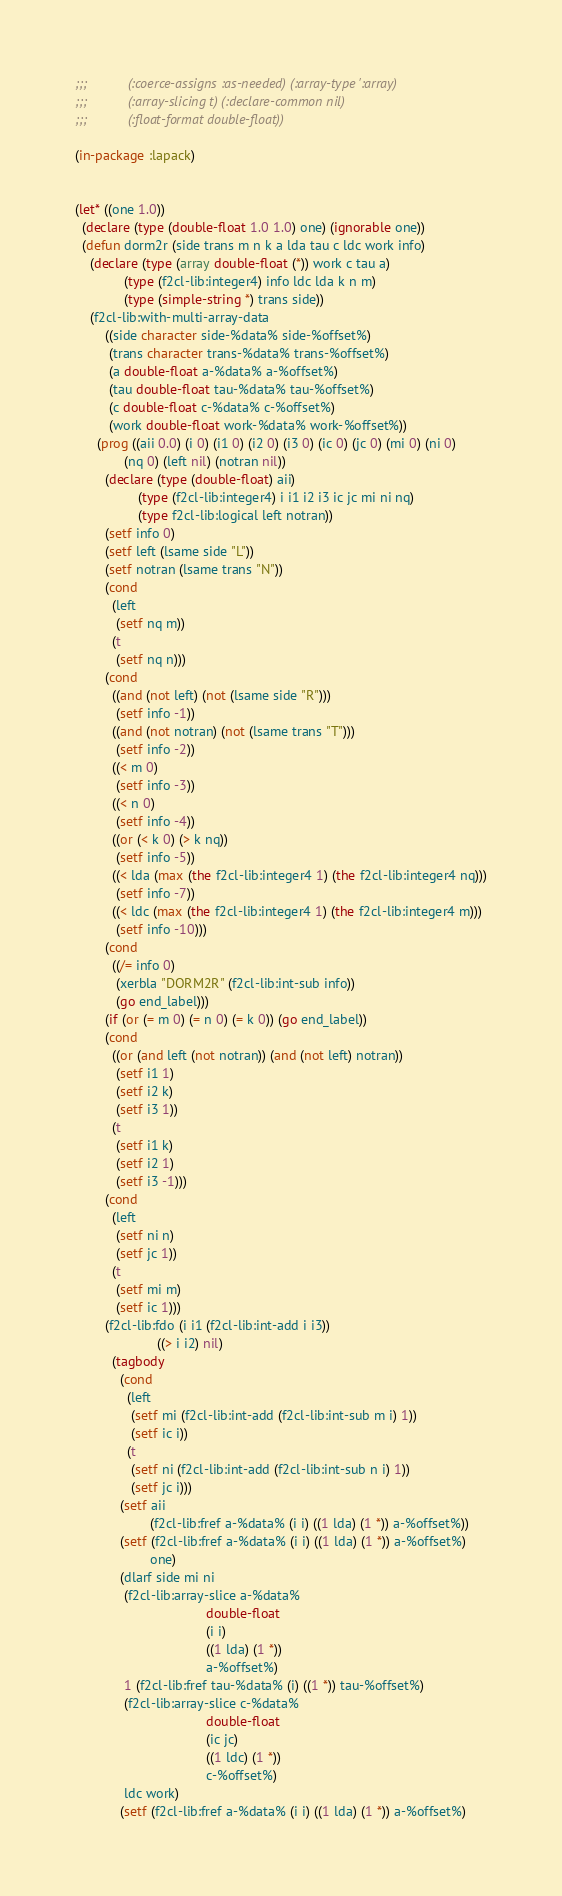<code> <loc_0><loc_0><loc_500><loc_500><_Lisp_>;;;           (:coerce-assigns :as-needed) (:array-type ':array)
;;;           (:array-slicing t) (:declare-common nil)
;;;           (:float-format double-float))

(in-package :lapack)


(let* ((one 1.0))
  (declare (type (double-float 1.0 1.0) one) (ignorable one))
  (defun dorm2r (side trans m n k a lda tau c ldc work info)
    (declare (type (array double-float (*)) work c tau a)
             (type (f2cl-lib:integer4) info ldc lda k n m)
             (type (simple-string *) trans side))
    (f2cl-lib:with-multi-array-data
        ((side character side-%data% side-%offset%)
         (trans character trans-%data% trans-%offset%)
         (a double-float a-%data% a-%offset%)
         (tau double-float tau-%data% tau-%offset%)
         (c double-float c-%data% c-%offset%)
         (work double-float work-%data% work-%offset%))
      (prog ((aii 0.0) (i 0) (i1 0) (i2 0) (i3 0) (ic 0) (jc 0) (mi 0) (ni 0)
             (nq 0) (left nil) (notran nil))
        (declare (type (double-float) aii)
                 (type (f2cl-lib:integer4) i i1 i2 i3 ic jc mi ni nq)
                 (type f2cl-lib:logical left notran))
        (setf info 0)
        (setf left (lsame side "L"))
        (setf notran (lsame trans "N"))
        (cond
          (left
           (setf nq m))
          (t
           (setf nq n)))
        (cond
          ((and (not left) (not (lsame side "R")))
           (setf info -1))
          ((and (not notran) (not (lsame trans "T")))
           (setf info -2))
          ((< m 0)
           (setf info -3))
          ((< n 0)
           (setf info -4))
          ((or (< k 0) (> k nq))
           (setf info -5))
          ((< lda (max (the f2cl-lib:integer4 1) (the f2cl-lib:integer4 nq)))
           (setf info -7))
          ((< ldc (max (the f2cl-lib:integer4 1) (the f2cl-lib:integer4 m)))
           (setf info -10)))
        (cond
          ((/= info 0)
           (xerbla "DORM2R" (f2cl-lib:int-sub info))
           (go end_label)))
        (if (or (= m 0) (= n 0) (= k 0)) (go end_label))
        (cond
          ((or (and left (not notran)) (and (not left) notran))
           (setf i1 1)
           (setf i2 k)
           (setf i3 1))
          (t
           (setf i1 k)
           (setf i2 1)
           (setf i3 -1)))
        (cond
          (left
           (setf ni n)
           (setf jc 1))
          (t
           (setf mi m)
           (setf ic 1)))
        (f2cl-lib:fdo (i i1 (f2cl-lib:int-add i i3))
                      ((> i i2) nil)
          (tagbody
            (cond
              (left
               (setf mi (f2cl-lib:int-add (f2cl-lib:int-sub m i) 1))
               (setf ic i))
              (t
               (setf ni (f2cl-lib:int-add (f2cl-lib:int-sub n i) 1))
               (setf jc i)))
            (setf aii
                    (f2cl-lib:fref a-%data% (i i) ((1 lda) (1 *)) a-%offset%))
            (setf (f2cl-lib:fref a-%data% (i i) ((1 lda) (1 *)) a-%offset%)
                    one)
            (dlarf side mi ni
             (f2cl-lib:array-slice a-%data%
                                   double-float
                                   (i i)
                                   ((1 lda) (1 *))
                                   a-%offset%)
             1 (f2cl-lib:fref tau-%data% (i) ((1 *)) tau-%offset%)
             (f2cl-lib:array-slice c-%data%
                                   double-float
                                   (ic jc)
                                   ((1 ldc) (1 *))
                                   c-%offset%)
             ldc work)
            (setf (f2cl-lib:fref a-%data% (i i) ((1 lda) (1 *)) a-%offset%)</code> 